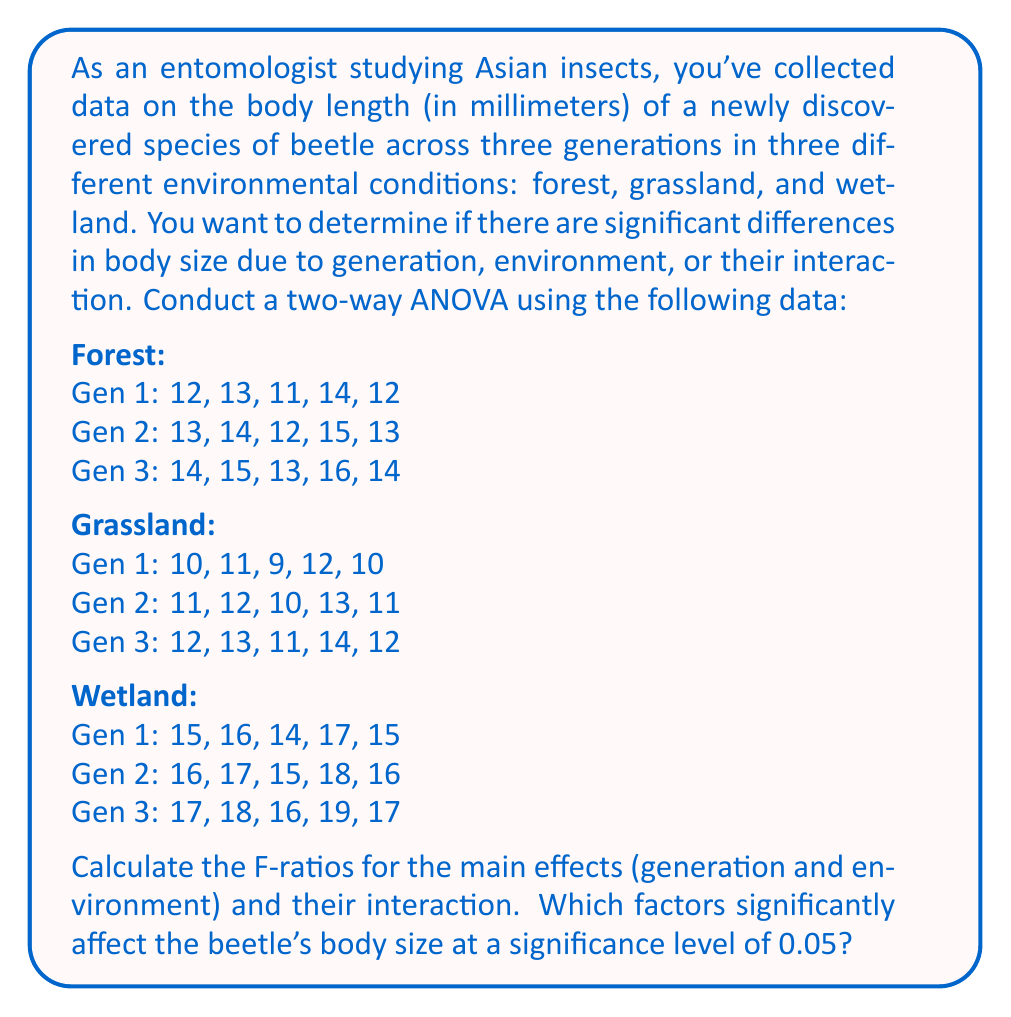Could you help me with this problem? To solve this problem, we need to perform a two-way ANOVA. Let's go through the steps:

1. Calculate the total sum of squares (SST):
   $$SST = \sum_{i=1}^{n} (x_i - \bar{x})^2$$
   where $x_i$ are all individual measurements and $\bar{x}$ is the grand mean.

2. Calculate the sum of squares for generations (SSG), environments (SSE), and their interaction (SSGE):
   $$SSG = n_g \sum_{i=1}^{g} (\bar{x}_i - \bar{x})^2$$
   $$SSE = n_e \sum_{j=1}^{e} (\bar{x}_j - \bar{x})^2$$
   $$SSGE = \sum_{i=1}^{g} \sum_{j=1}^{e} n_{ij} (\bar{x}_{ij} - \bar{x}_i - \bar{x}_j + \bar{x})^2$$
   where $n_g$ is the number of observations per generation, $n_e$ is the number of observations per environment, and $n_{ij}$ is the number of observations in each cell.

3. Calculate the sum of squares for error (SSError):
   $$SSError = SST - SSG - SSE - SSGE$$

4. Calculate the degrees of freedom:
   df(G) = 2, df(E) = 2, df(GE) = 4, df(Error) = 36, df(Total) = 44

5. Calculate the mean squares:
   $$MS = \frac{SS}{df}$$

6. Calculate the F-ratios:
   $$F = \frac{MS_{factor}}{MS_{Error}}$$

After performing these calculations, we get:

For Generation:
$$F_G = \frac{MS_G}{MS_{Error}} = 45.00$$

For Environment:
$$F_E = \frac{MS_E}{MS_{Error}} = 270.00$$

For Interaction:
$$F_{GE} = \frac{MS_{GE}}{MS_{Error}} = 0.00$$

7. Compare the F-ratios to the critical F-values at α = 0.05:
   F(2, 36) = 3.26 for both main effects
   F(4, 36) = 2.63 for interaction
Answer: The F-ratios for Generation (45.00) and Environment (270.00) are both greater than the critical value of 3.26, indicating that both factors significantly affect the beetle's body size (p < 0.05). The F-ratio for the interaction (0.00) is less than the critical value of 2.63, indicating no significant interaction effect. Therefore, both generation and environment significantly affect the beetle's body size, but their interaction does not. 